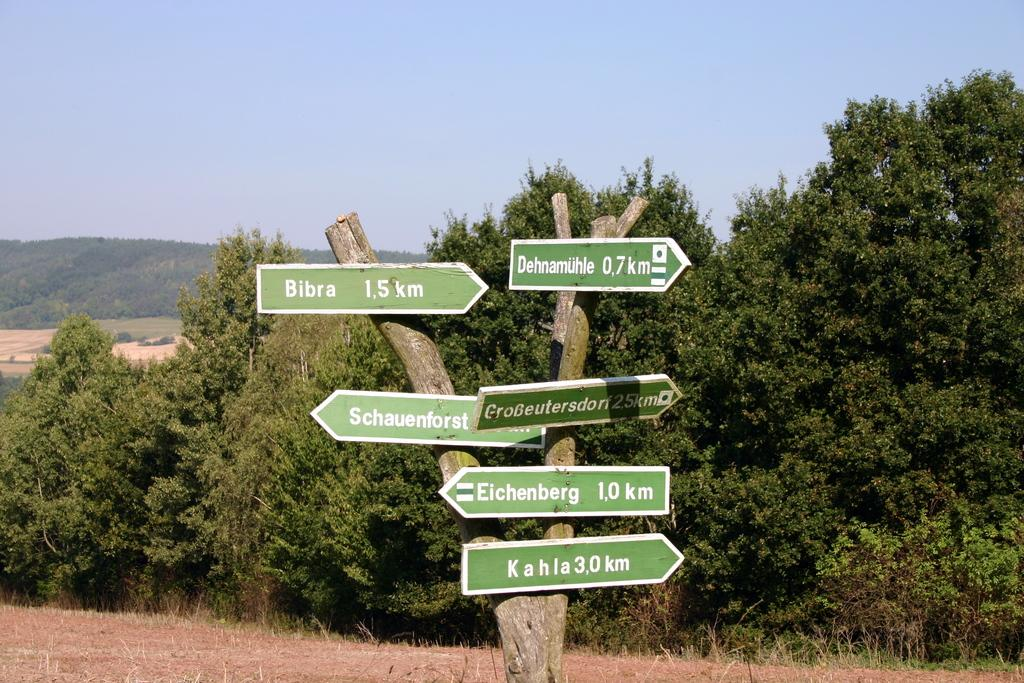<image>
Give a short and clear explanation of the subsequent image. The green sign indicates Bibra is 1.5 km to the right. 